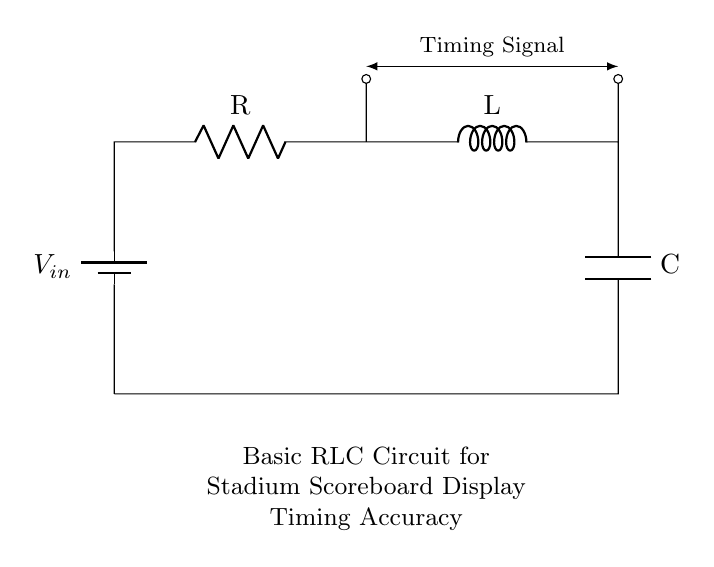What is the input voltage of this circuit? The input voltage, labeled as V_in, is the potential difference applied at the input of the circuit. This value influences the entire circuitry, as it provides the initial energy needed for the RLC components to function.
Answer: V_in What components are shown in this circuit diagram? The circuit contains three main components: a resistor, an inductor, and a capacitor, connected in series between the input voltage and ground. This configuration is characteristic of RLC circuits used for timing and filtering applications.
Answer: Resistor, Inductor, Capacitor What type of circuit is represented in the diagram? The circuit depicted is a basic RLC circuit, which consists of a resistor, an inductor, and a capacitor arranged in a loop. This type of circuit is commonly used for timing applications and to filter signals in various electronic devices, including scoreboard displays.
Answer: RLC Circuit How does the inductor influence the timing signal? The inductor opposes changes in current, acting as a delay element in the circuit. This property helps in tuning the timing responses of the circuit to reach resonance when combined with the capacitor, impacting the timing signal observed at the output.
Answer: Delays the current What is the purpose of the capacitor in the circuit? The capacitor stores and releases electrical energy, contributing to the timing characteristics of the circuit. It works with the inductor to create oscillations or delay in the timing signal, vital for precise scoreboard displays during events.
Answer: Stores energy Which component produces the timing signal in this circuit? The timing signal is produced as a result of the interactions between the inductor and capacitor, where their energy transfer results in oscillation, generating the timing signal observed. Thus, while the timing signal is a product of the whole circuit, the inductor and capacitor are primarily responsible.
Answer: Inductor and Capacitor How are the components connected in this circuit? The components are connected in series, which means that the output of one component leads directly into the next. This series connection is essential for the proper functioning of RLC circuits to control the timing characteristics effectively.
Answer: In series 